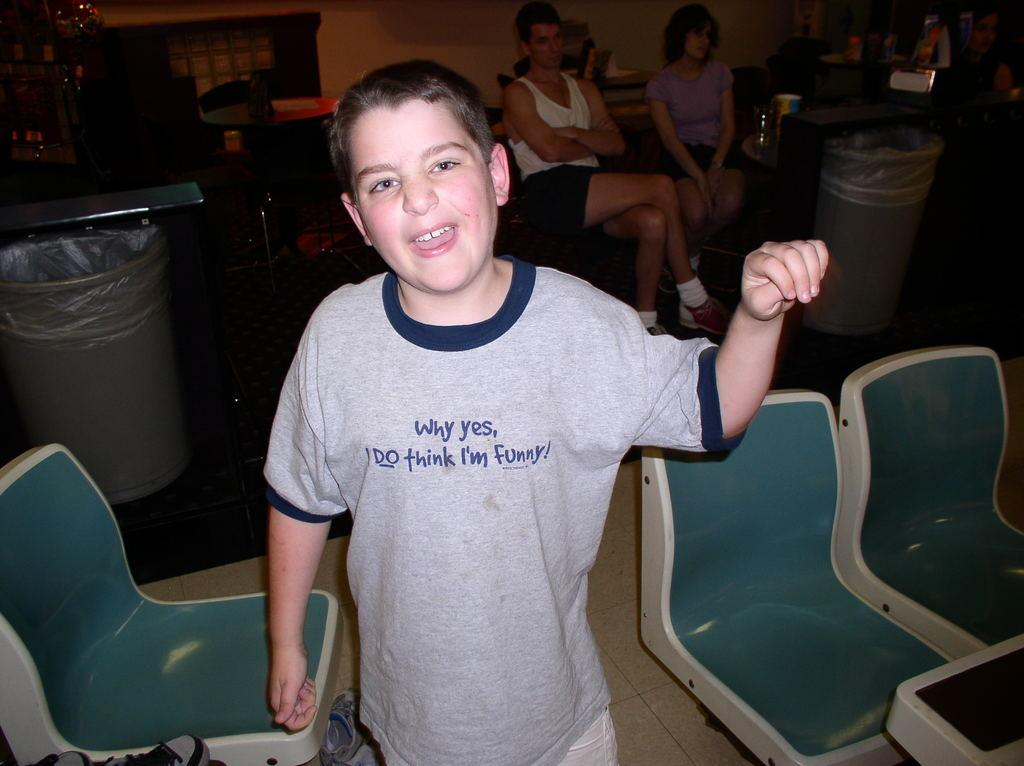Who is the main subject in the image? There is a boy in the image. What is the boy doing in the image? The boy is standing and smiling. What objects are near the boy? There are chairs in front of and beside the boy, as well as a bin at the back. Are there any other people in the image? Yes, there are two women sitting at the back of the boy. What type of furniture is present in the image? There is a wooden table in the image. What can be seen in the background of the image? There is a wall visible in the image. What is the chance of solving the riddle written on the wall in the image? There is no riddle written on the wall in the image, so it is not possible to determine the chance of solving it. 